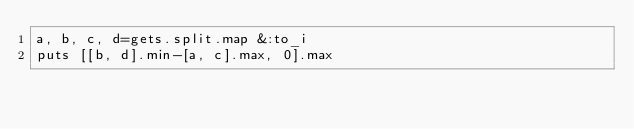<code> <loc_0><loc_0><loc_500><loc_500><_Ruby_>a, b, c, d=gets.split.map &:to_i
puts [[b, d].min-[a, c].max, 0].max
</code> 